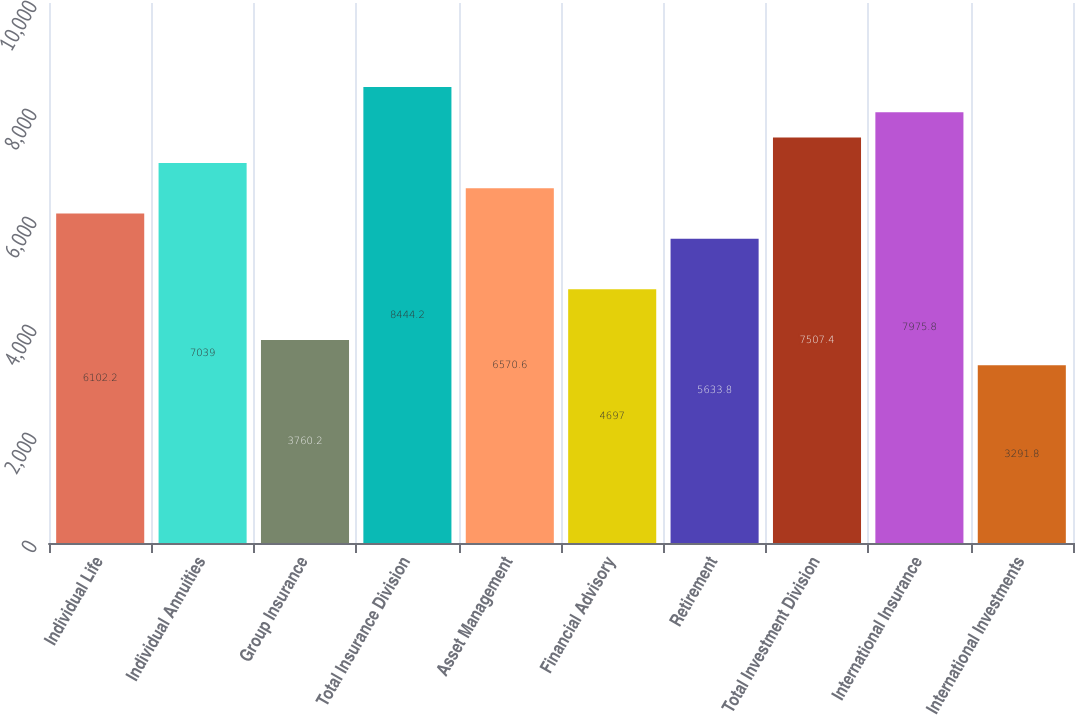<chart> <loc_0><loc_0><loc_500><loc_500><bar_chart><fcel>Individual Life<fcel>Individual Annuities<fcel>Group Insurance<fcel>Total Insurance Division<fcel>Asset Management<fcel>Financial Advisory<fcel>Retirement<fcel>Total Investment Division<fcel>International Insurance<fcel>International Investments<nl><fcel>6102.2<fcel>7039<fcel>3760.2<fcel>8444.2<fcel>6570.6<fcel>4697<fcel>5633.8<fcel>7507.4<fcel>7975.8<fcel>3291.8<nl></chart> 